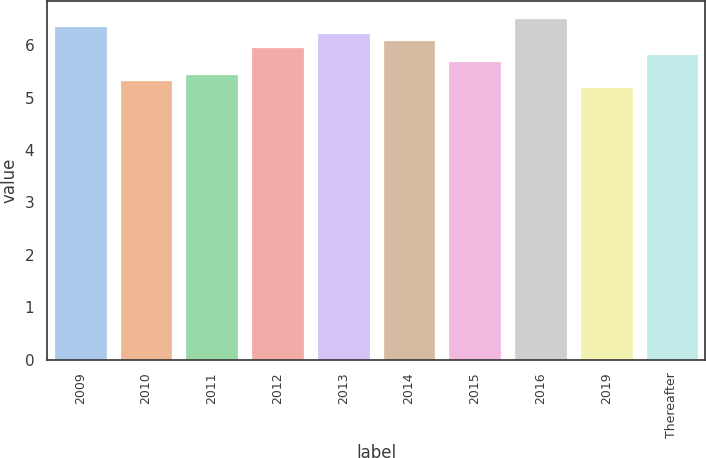Convert chart to OTSL. <chart><loc_0><loc_0><loc_500><loc_500><bar_chart><fcel>2009<fcel>2010<fcel>2011<fcel>2012<fcel>2013<fcel>2014<fcel>2015<fcel>2016<fcel>2019<fcel>Thereafter<nl><fcel>6.36<fcel>5.33<fcel>5.46<fcel>5.97<fcel>6.23<fcel>6.1<fcel>5.71<fcel>6.52<fcel>5.2<fcel>5.84<nl></chart> 